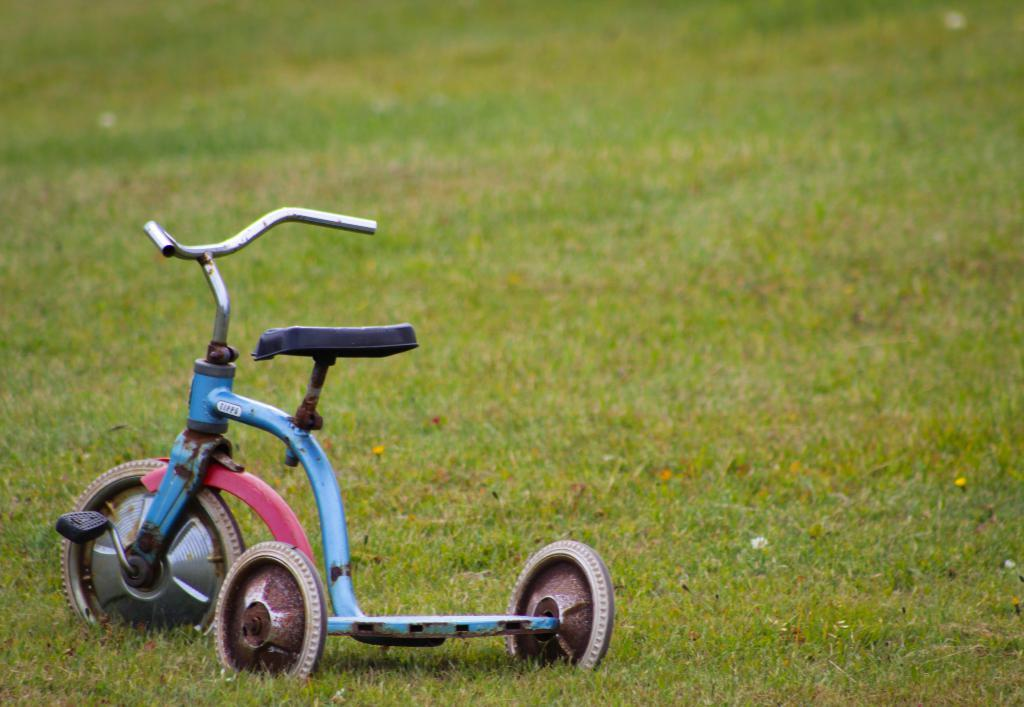What is the main subject of the image? There is a small vehicle in the image. Where is the vehicle located? The vehicle is on the grass. What type of poison is being used to clean the chair in the image? There is no chair or poison present in the image; it only features a small vehicle on the grass. 